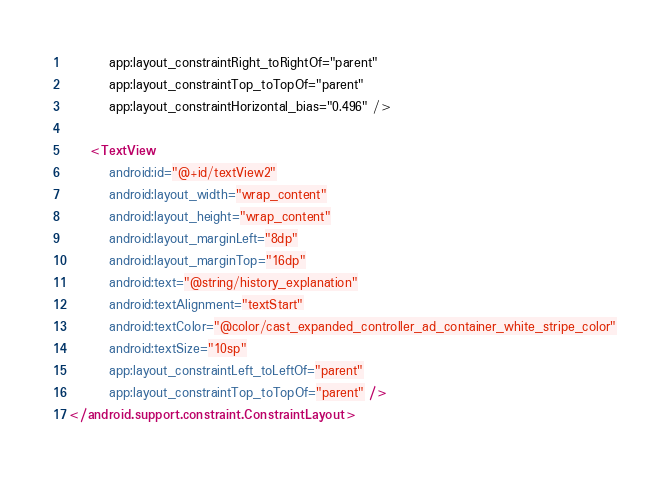<code> <loc_0><loc_0><loc_500><loc_500><_XML_>        app:layout_constraintRight_toRightOf="parent"
        app:layout_constraintTop_toTopOf="parent"
        app:layout_constraintHorizontal_bias="0.496" />

    <TextView
        android:id="@+id/textView2"
        android:layout_width="wrap_content"
        android:layout_height="wrap_content"
        android:layout_marginLeft="8dp"
        android:layout_marginTop="16dp"
        android:text="@string/history_explanation"
        android:textAlignment="textStart"
        android:textColor="@color/cast_expanded_controller_ad_container_white_stripe_color"
        android:textSize="10sp"
        app:layout_constraintLeft_toLeftOf="parent"
        app:layout_constraintTop_toTopOf="parent" />
</android.support.constraint.ConstraintLayout></code> 